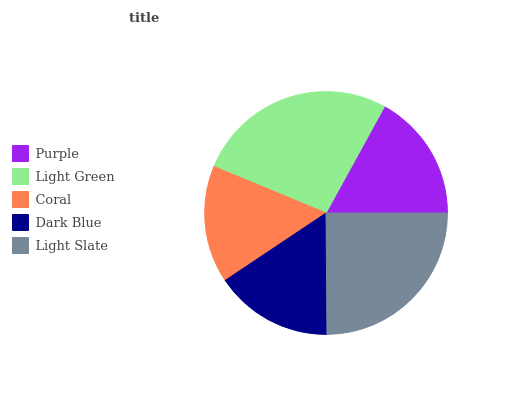Is Coral the minimum?
Answer yes or no. Yes. Is Light Green the maximum?
Answer yes or no. Yes. Is Light Green the minimum?
Answer yes or no. No. Is Coral the maximum?
Answer yes or no. No. Is Light Green greater than Coral?
Answer yes or no. Yes. Is Coral less than Light Green?
Answer yes or no. Yes. Is Coral greater than Light Green?
Answer yes or no. No. Is Light Green less than Coral?
Answer yes or no. No. Is Purple the high median?
Answer yes or no. Yes. Is Purple the low median?
Answer yes or no. Yes. Is Light Green the high median?
Answer yes or no. No. Is Light Green the low median?
Answer yes or no. No. 